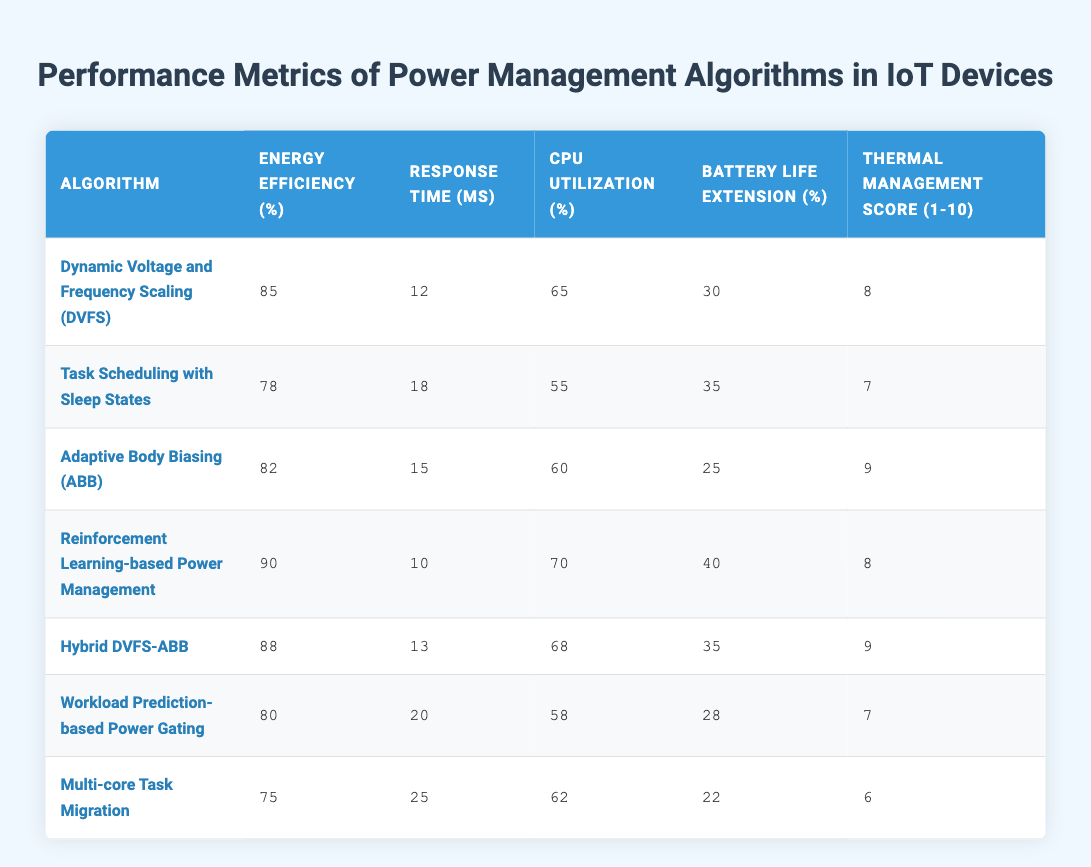What is the energy efficiency of the reinforcement learning-based power management algorithm? According to the table, the energy efficiency value corresponding to the "Reinforcement Learning-based Power Management" algorithm is 90%.
Answer: 90% Which algorithm shows the highest CPU utilization percentage? By examining the CPU utilization values, "Reinforcement Learning-based Power Management" has the highest at 70%, compared to others which have lower values.
Answer: 70% What is the average response time of all the algorithms? The response times are 12, 18, 15, 10, 13, 20, and 25. To find the average, sum these values: 12 + 18 + 15 + 10 + 13 + 20 + 25 = 123. There are 7 algorithms, so the average response time is 123/7 ≈ 17.57 ms.
Answer: 17.57 ms Is the thermal management score of "Hybrid DVFS-ABB" greater than that of "Task Scheduling with Sleep States"? The thermal management score for "Hybrid DVFS-ABB" is 9, while "Task Scheduling with Sleep States" has a score of 7. Therefore, "Hybrid DVFS-ABB" does have a higher score.
Answer: Yes Which algorithm has the lowest battery life extension percentage? Looking through the battery life extension values, "Multi-core Task Migration" has the lowest at 22%.
Answer: 22% What is the sum of energy efficiency percentages for all algorithms? The energy efficiency percentages are 85, 78, 82, 90, 88, 80, and 75. Adding these together: 85 + 78 + 82 + 90 + 88 + 80 + 75 = 588.
Answer: 588 How many algorithms have a thermal management score of 9? Upon reviewing the thermal management scores, two algorithms have the score of 9: "Adaptive Body Biasing (ABB)" and "Hybrid DVFS-ABB."
Answer: 2 Which algorithm has the longest response time? The response times listed are 12, 18, 15, 10, 13, 20, and 25 ms. "Multi-core Task Migration" has the longest response time of 25 ms.
Answer: 25 ms Does the "Task Scheduling with Sleep States" outperform "Workload Prediction-based Power Gating" in terms of energy efficiency? The energy efficiency for "Task Scheduling with Sleep States" is 78%, while "Workload Prediction-based Power Gating" has 80%. Since 80% is higher, "Task Scheduling with Sleep States" does not outperform it.
Answer: No 